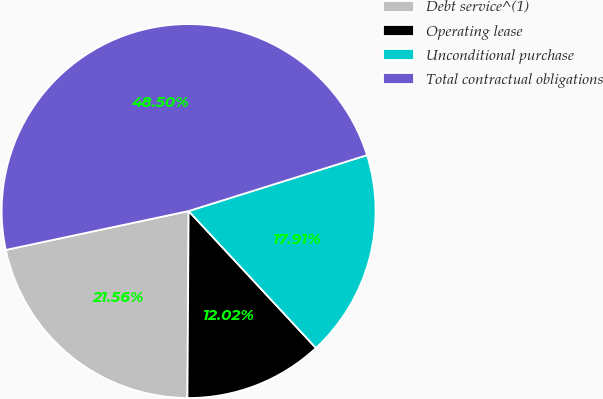Convert chart to OTSL. <chart><loc_0><loc_0><loc_500><loc_500><pie_chart><fcel>Debt service^(1)<fcel>Operating lease<fcel>Unconditional purchase<fcel>Total contractual obligations<nl><fcel>21.56%<fcel>12.02%<fcel>17.91%<fcel>48.5%<nl></chart> 